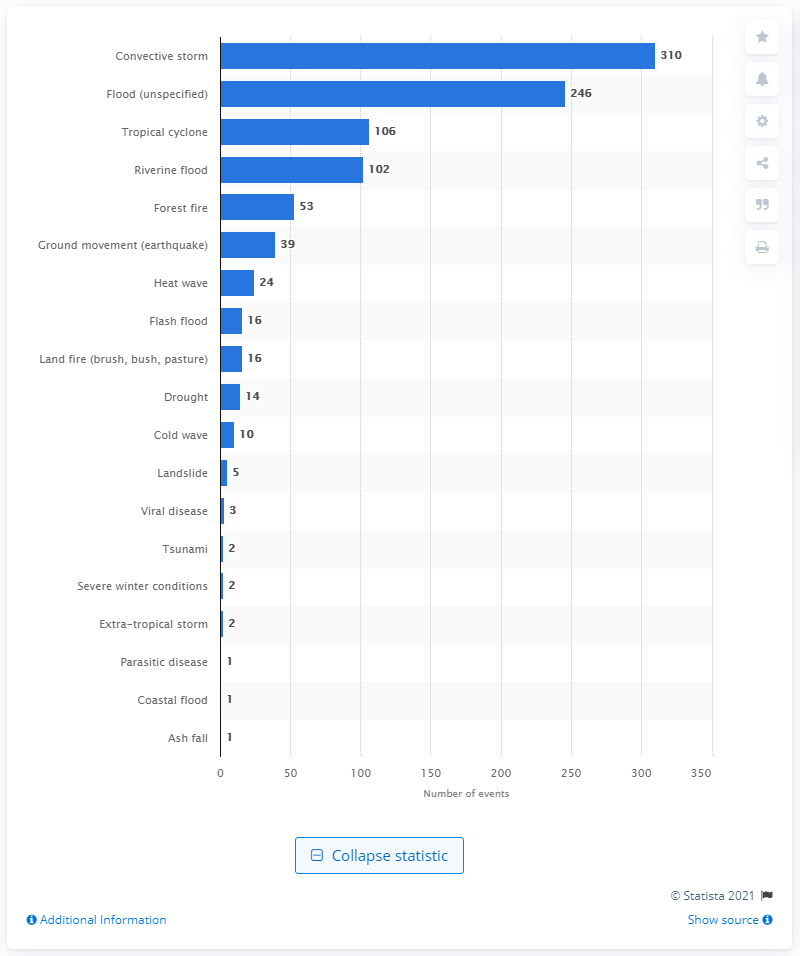Give some essential details in this illustration. During the period from 1900 to 2016, a total of 24 heat waves have occurred in the United States. 